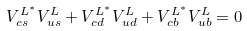<formula> <loc_0><loc_0><loc_500><loc_500>V _ { c s } ^ { L ^ { * } } V _ { u s } ^ { L } + V _ { c d } ^ { L ^ { * } } V _ { u d } ^ { L } + V _ { c b } ^ { L ^ { * } } V _ { u b } ^ { L } = 0</formula> 